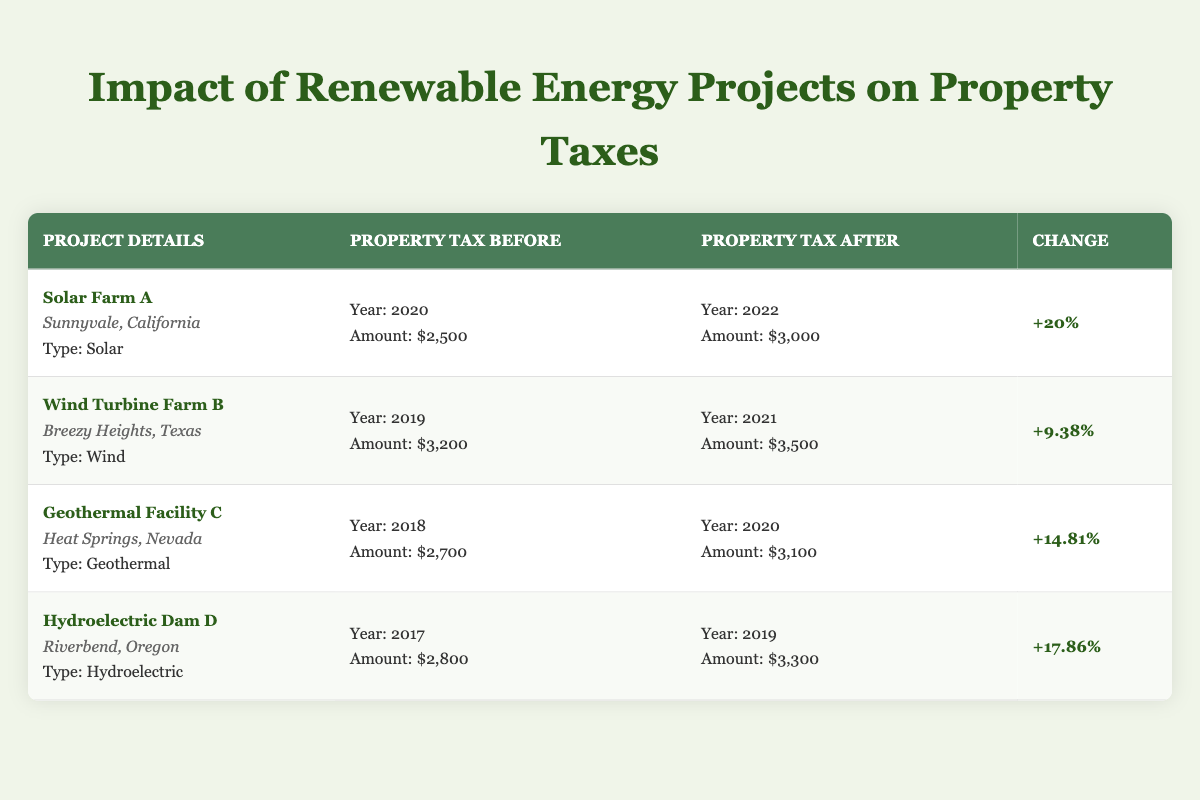What was the property tax for Solar Farm A before the project? The table states that for Solar Farm A, the property tax before the project was $2,500 in the year 2020.
Answer: $2,500 What is the property tax amount after the Wind Turbine Farm B project? According to the table, the property tax for Wind Turbine Farm B after the project was $3,500 in 2021.
Answer: $3,500 Was the percentage increase in property tax after the Hydroelectric Dam D project greater than 15%? The table indicates that the percentage increase in property tax after Hydroelectric Dam D was +17.86%, which is indeed greater than 15%.
Answer: Yes Which renewable energy project had the highest change percentage in property taxes? By checking the change percentages from the table, Solar Farm A had the highest at 20%, compared to all other projects.
Answer: Solar Farm A What was the average property tax before the renewable energy projects? The property taxes before the projects were: $2,500, $3,200, $2,700, and $2,800. To find the average, add them: 2,500 + 3,200 + 2,700 + 2,800 = 11,200. Then divide by 4 (as there are 4 data points): 11,200 / 4 = 2,800.
Answer: $2,800 